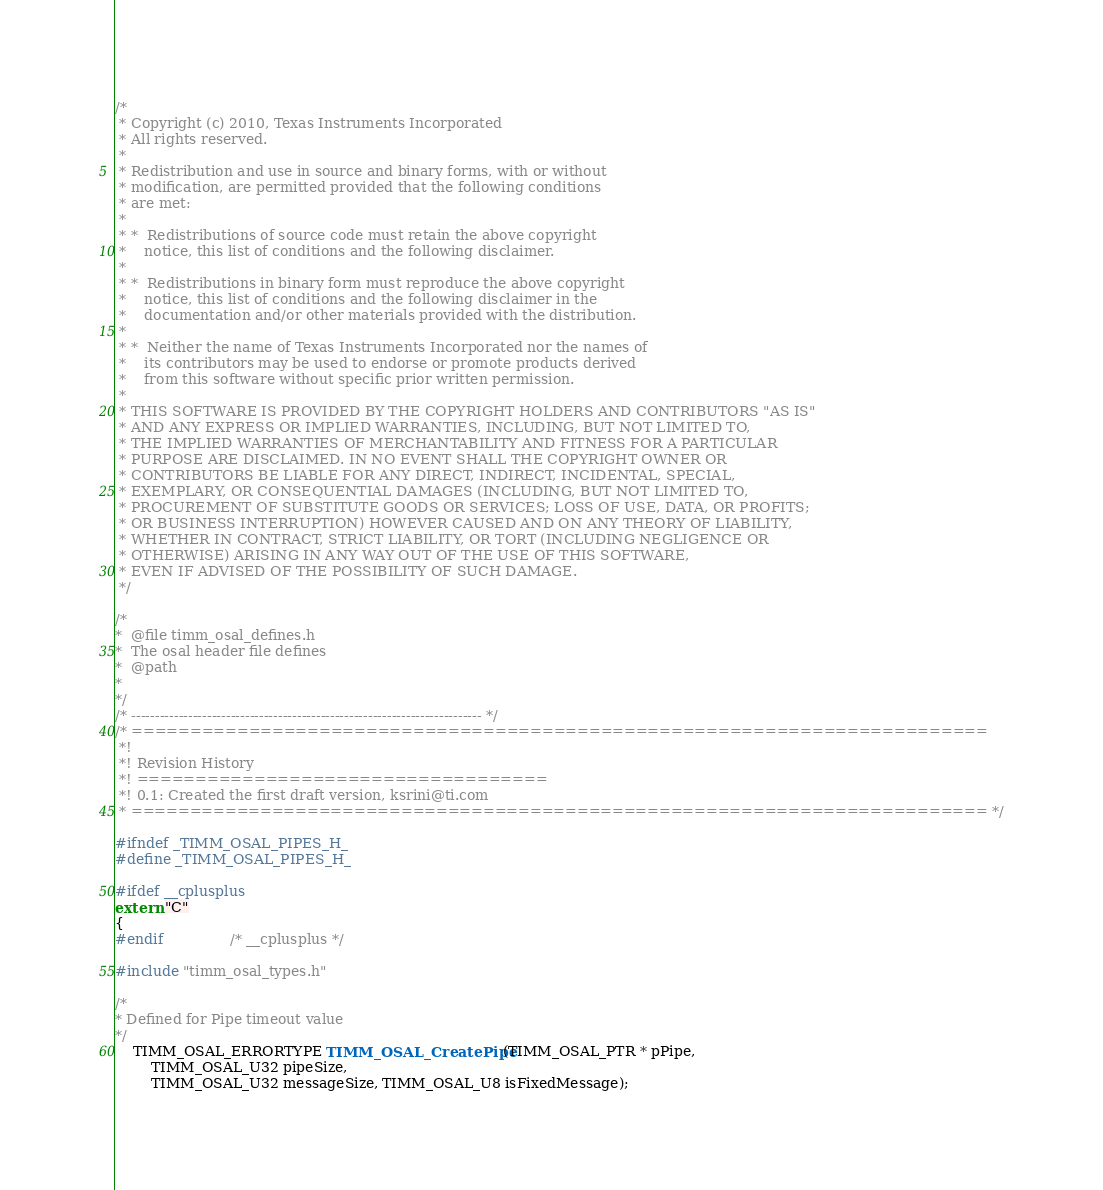Convert code to text. <code><loc_0><loc_0><loc_500><loc_500><_C_>/*
 * Copyright (c) 2010, Texas Instruments Incorporated
 * All rights reserved.
 *
 * Redistribution and use in source and binary forms, with or without
 * modification, are permitted provided that the following conditions
 * are met:
 *
 * *  Redistributions of source code must retain the above copyright
 *    notice, this list of conditions and the following disclaimer.
 *
 * *  Redistributions in binary form must reproduce the above copyright
 *    notice, this list of conditions and the following disclaimer in the
 *    documentation and/or other materials provided with the distribution.
 *
 * *  Neither the name of Texas Instruments Incorporated nor the names of
 *    its contributors may be used to endorse or promote products derived
 *    from this software without specific prior written permission.
 *
 * THIS SOFTWARE IS PROVIDED BY THE COPYRIGHT HOLDERS AND CONTRIBUTORS "AS IS"
 * AND ANY EXPRESS OR IMPLIED WARRANTIES, INCLUDING, BUT NOT LIMITED TO,
 * THE IMPLIED WARRANTIES OF MERCHANTABILITY AND FITNESS FOR A PARTICULAR
 * PURPOSE ARE DISCLAIMED. IN NO EVENT SHALL THE COPYRIGHT OWNER OR
 * CONTRIBUTORS BE LIABLE FOR ANY DIRECT, INDIRECT, INCIDENTAL, SPECIAL,
 * EXEMPLARY, OR CONSEQUENTIAL DAMAGES (INCLUDING, BUT NOT LIMITED TO,
 * PROCUREMENT OF SUBSTITUTE GOODS OR SERVICES; LOSS OF USE, DATA, OR PROFITS;
 * OR BUSINESS INTERRUPTION) HOWEVER CAUSED AND ON ANY THEORY OF LIABILITY,
 * WHETHER IN CONTRACT, STRICT LIABILITY, OR TORT (INCLUDING NEGLIGENCE OR
 * OTHERWISE) ARISING IN ANY WAY OUT OF THE USE OF THIS SOFTWARE,
 * EVEN IF ADVISED OF THE POSSIBILITY OF SUCH DAMAGE.
 */

/*
*  @file timm_osal_defines.h
*  The osal header file defines
*  @path
*
*/
/* -------------------------------------------------------------------------- */
/* =========================================================================
 *!
 *! Revision History
 *! ===================================
 *! 0.1: Created the first draft version, ksrini@ti.com
 * ========================================================================= */

#ifndef _TIMM_OSAL_PIPES_H_
#define _TIMM_OSAL_PIPES_H_

#ifdef __cplusplus
extern "C"
{
#endif				/* __cplusplus */

#include "timm_osal_types.h"

/*
* Defined for Pipe timeout value
*/
	TIMM_OSAL_ERRORTYPE TIMM_OSAL_CreatePipe(TIMM_OSAL_PTR * pPipe,
	    TIMM_OSAL_U32 pipeSize,
	    TIMM_OSAL_U32 messageSize, TIMM_OSAL_U8 isFixedMessage);
</code> 